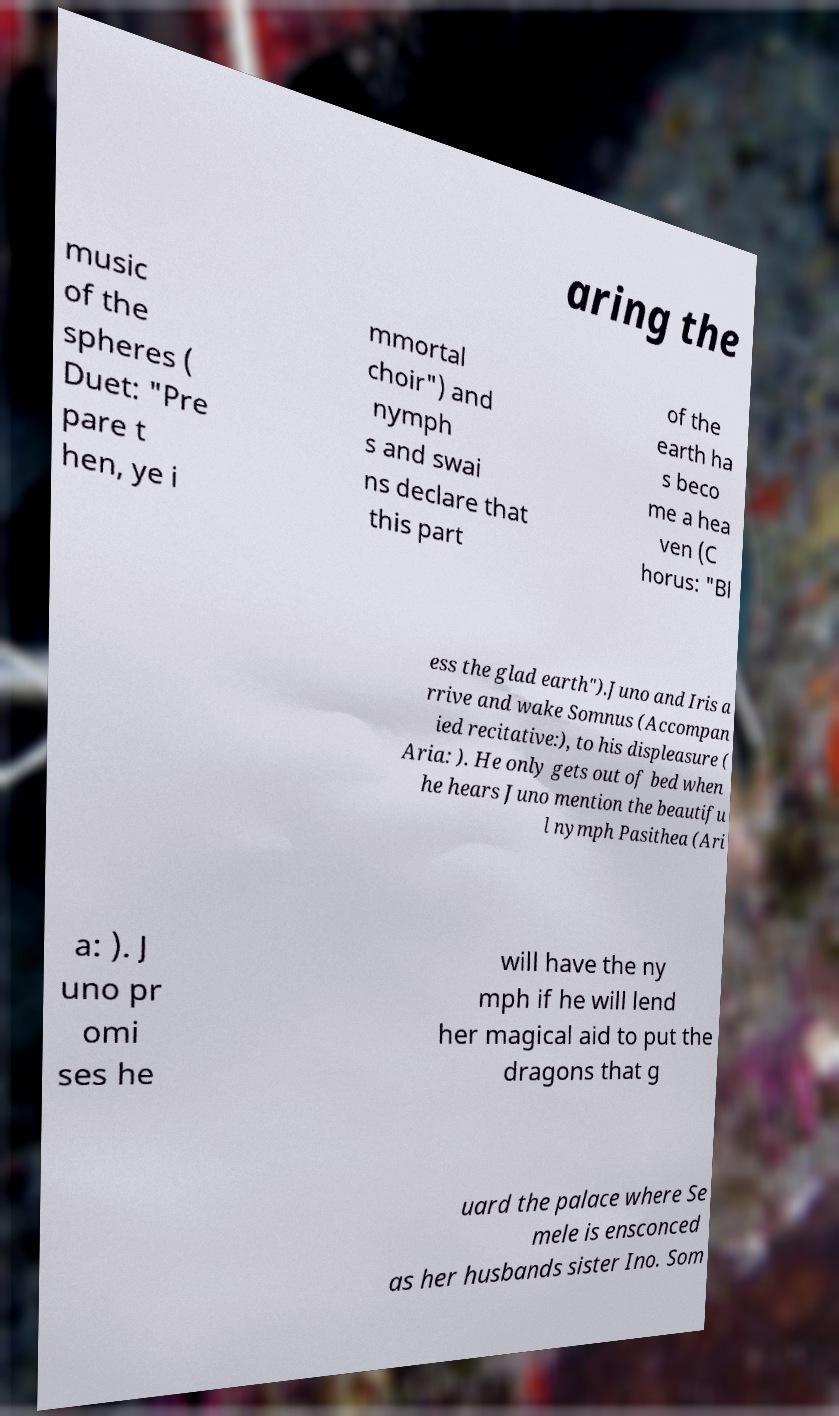Can you accurately transcribe the text from the provided image for me? aring the music of the spheres ( Duet: "Pre pare t hen, ye i mmortal choir") and nymph s and swai ns declare that this part of the earth ha s beco me a hea ven (C horus: "Bl ess the glad earth").Juno and Iris a rrive and wake Somnus (Accompan ied recitative:), to his displeasure ( Aria: ). He only gets out of bed when he hears Juno mention the beautifu l nymph Pasithea (Ari a: ). J uno pr omi ses he will have the ny mph if he will lend her magical aid to put the dragons that g uard the palace where Se mele is ensconced as her husbands sister Ino. Som 